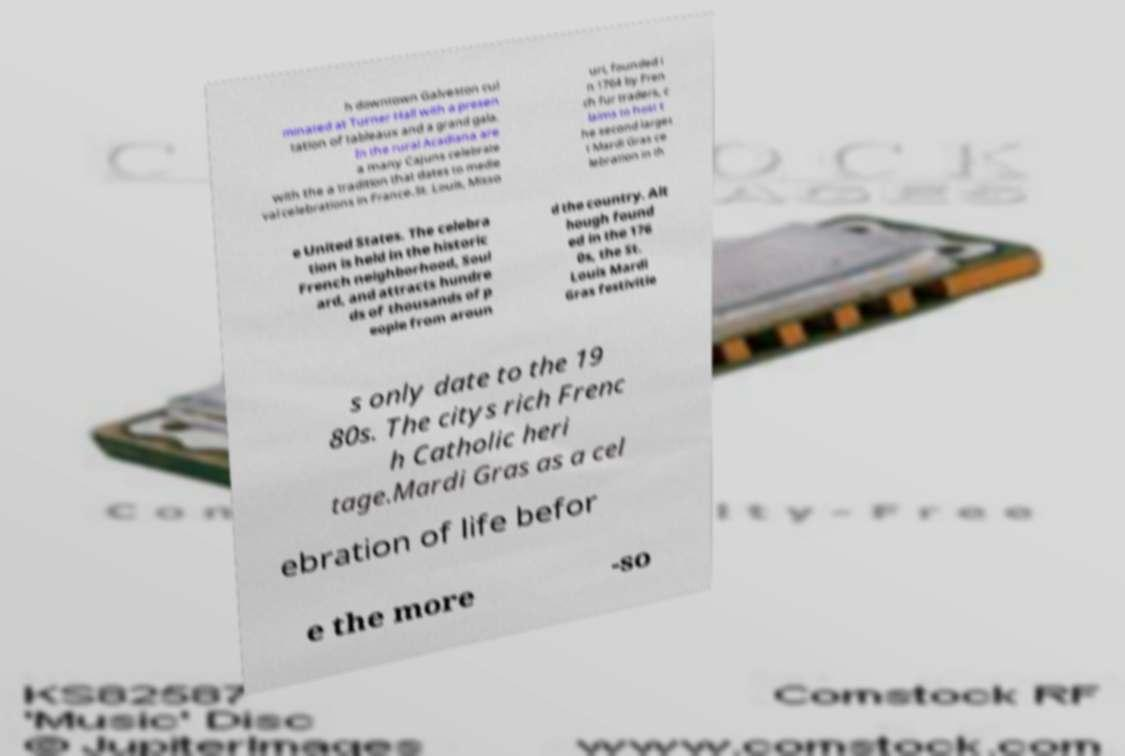Could you assist in decoding the text presented in this image and type it out clearly? h downtown Galveston cul minated at Turner Hall with a presen tation of tableaux and a grand gala. In the rural Acadiana are a many Cajuns celebrate with the a tradition that dates to medie val celebrations in France.St. Louis, Misso uri, founded i n 1764 by Fren ch fur traders, c laims to host t he second larges t Mardi Gras ce lebration in th e United States. The celebra tion is held in the historic French neighborhood, Soul ard, and attracts hundre ds of thousands of p eople from aroun d the country. Alt hough found ed in the 176 0s, the St. Louis Mardi Gras festivitie s only date to the 19 80s. The citys rich Frenc h Catholic heri tage.Mardi Gras as a cel ebration of life befor e the more -so 